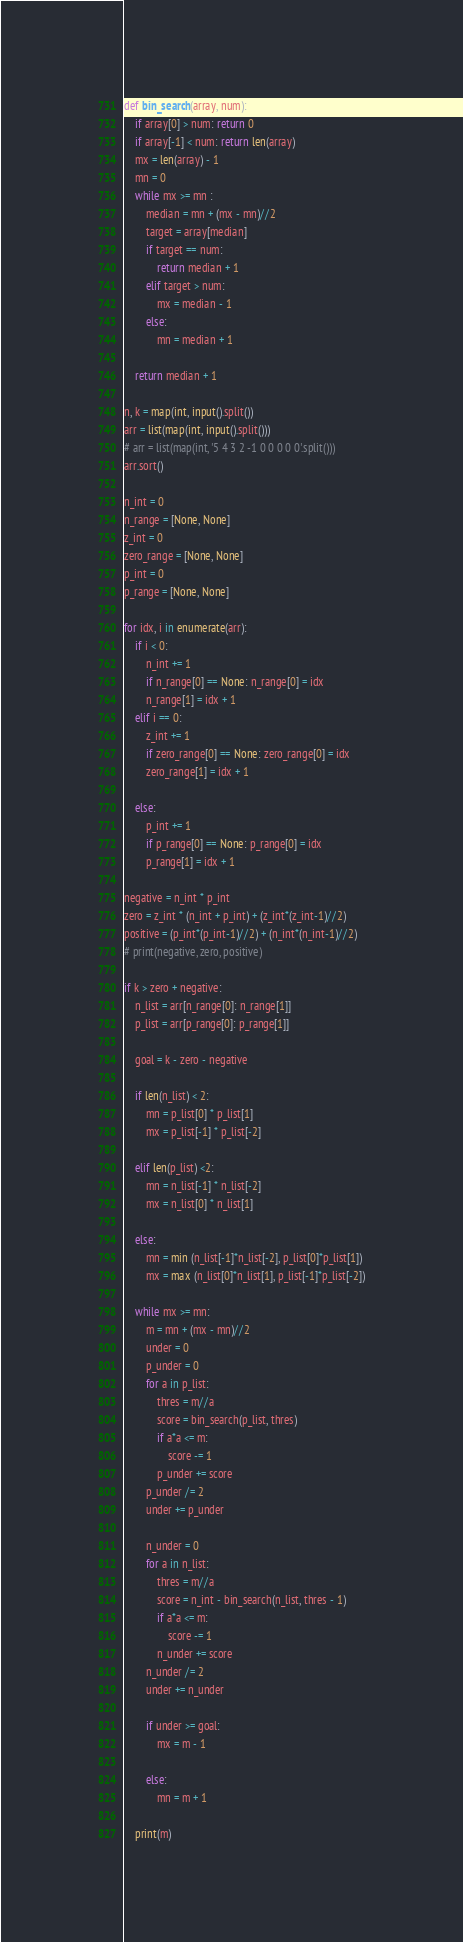<code> <loc_0><loc_0><loc_500><loc_500><_Python_>def bin_search(array, num):
    if array[0] > num: return 0
    if array[-1] < num: return len(array)
    mx = len(array) - 1
    mn = 0
    while mx >= mn :
        median = mn + (mx - mn)//2 
        target = array[median]
        if target == num:
            return median + 1
        elif target > num:
            mx = median - 1
        else:
            mn = median + 1

    return median + 1

n, k = map(int, input().split())
arr = list(map(int, input().split()))
# arr = list(map(int, '5 4 3 2 -1 0 0 0 0 0'.split()))
arr.sort()

n_int = 0
n_range = [None, None]
z_int = 0
zero_range = [None, None]
p_int = 0
p_range = [None, None]

for idx, i in enumerate(arr):
    if i < 0:
        n_int += 1
        if n_range[0] == None: n_range[0] = idx
        n_range[1] = idx + 1
    elif i == 0:
        z_int += 1
        if zero_range[0] == None: zero_range[0] = idx
        zero_range[1] = idx + 1
    
    else:
        p_int += 1
        if p_range[0] == None: p_range[0] = idx
        p_range[1] = idx + 1

negative = n_int * p_int
zero = z_int * (n_int + p_int) + (z_int*(z_int-1)//2)
positive = (p_int*(p_int-1)//2) + (n_int*(n_int-1)//2)
# print(negative, zero, positive)

if k > zero + negative:
    n_list = arr[n_range[0]: n_range[1]]
    p_list = arr[p_range[0]: p_range[1]]

    goal = k - zero - negative

    if len(n_list) < 2:
        mn = p_list[0] * p_list[1]
        mx = p_list[-1] * p_list[-2]
    
    elif len(p_list) <2:
        mn = n_list[-1] * n_list[-2]
        mx = n_list[0] * n_list[1]
     
    else:
        mn = min (n_list[-1]*n_list[-2], p_list[0]*p_list[1])
        mx = max (n_list[0]*n_list[1], p_list[-1]*p_list[-2])

    while mx >= mn:
        m = mn + (mx - mn)//2
        under = 0
        p_under = 0
        for a in p_list:
            thres = m//a
            score = bin_search(p_list, thres)
            if a*a <= m:
                score -= 1
            p_under += score
        p_under /= 2
        under += p_under
        
        n_under = 0
        for a in n_list:
            thres = m//a
            score = n_int - bin_search(n_list, thres - 1)
            if a*a <= m:
                score -= 1
            n_under += score
        n_under /= 2
        under += n_under

        if under >= goal:
            mx = m - 1
        
        else:
            mn = m + 1
    
    print(m)


</code> 